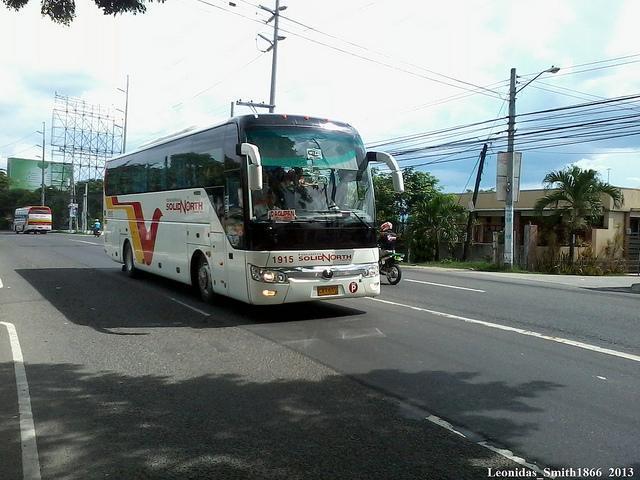How many buses are there?
Give a very brief answer. 2. 